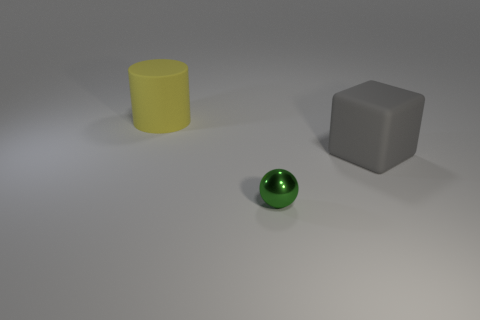Add 1 large matte cubes. How many objects exist? 4 Subtract 0 blue cylinders. How many objects are left? 3 Subtract all blocks. How many objects are left? 2 Subtract all gray cylinders. Subtract all brown spheres. How many cylinders are left? 1 Subtract all tiny gray rubber objects. Subtract all big gray matte things. How many objects are left? 2 Add 3 large gray matte things. How many large gray matte things are left? 4 Add 3 large rubber objects. How many large rubber objects exist? 5 